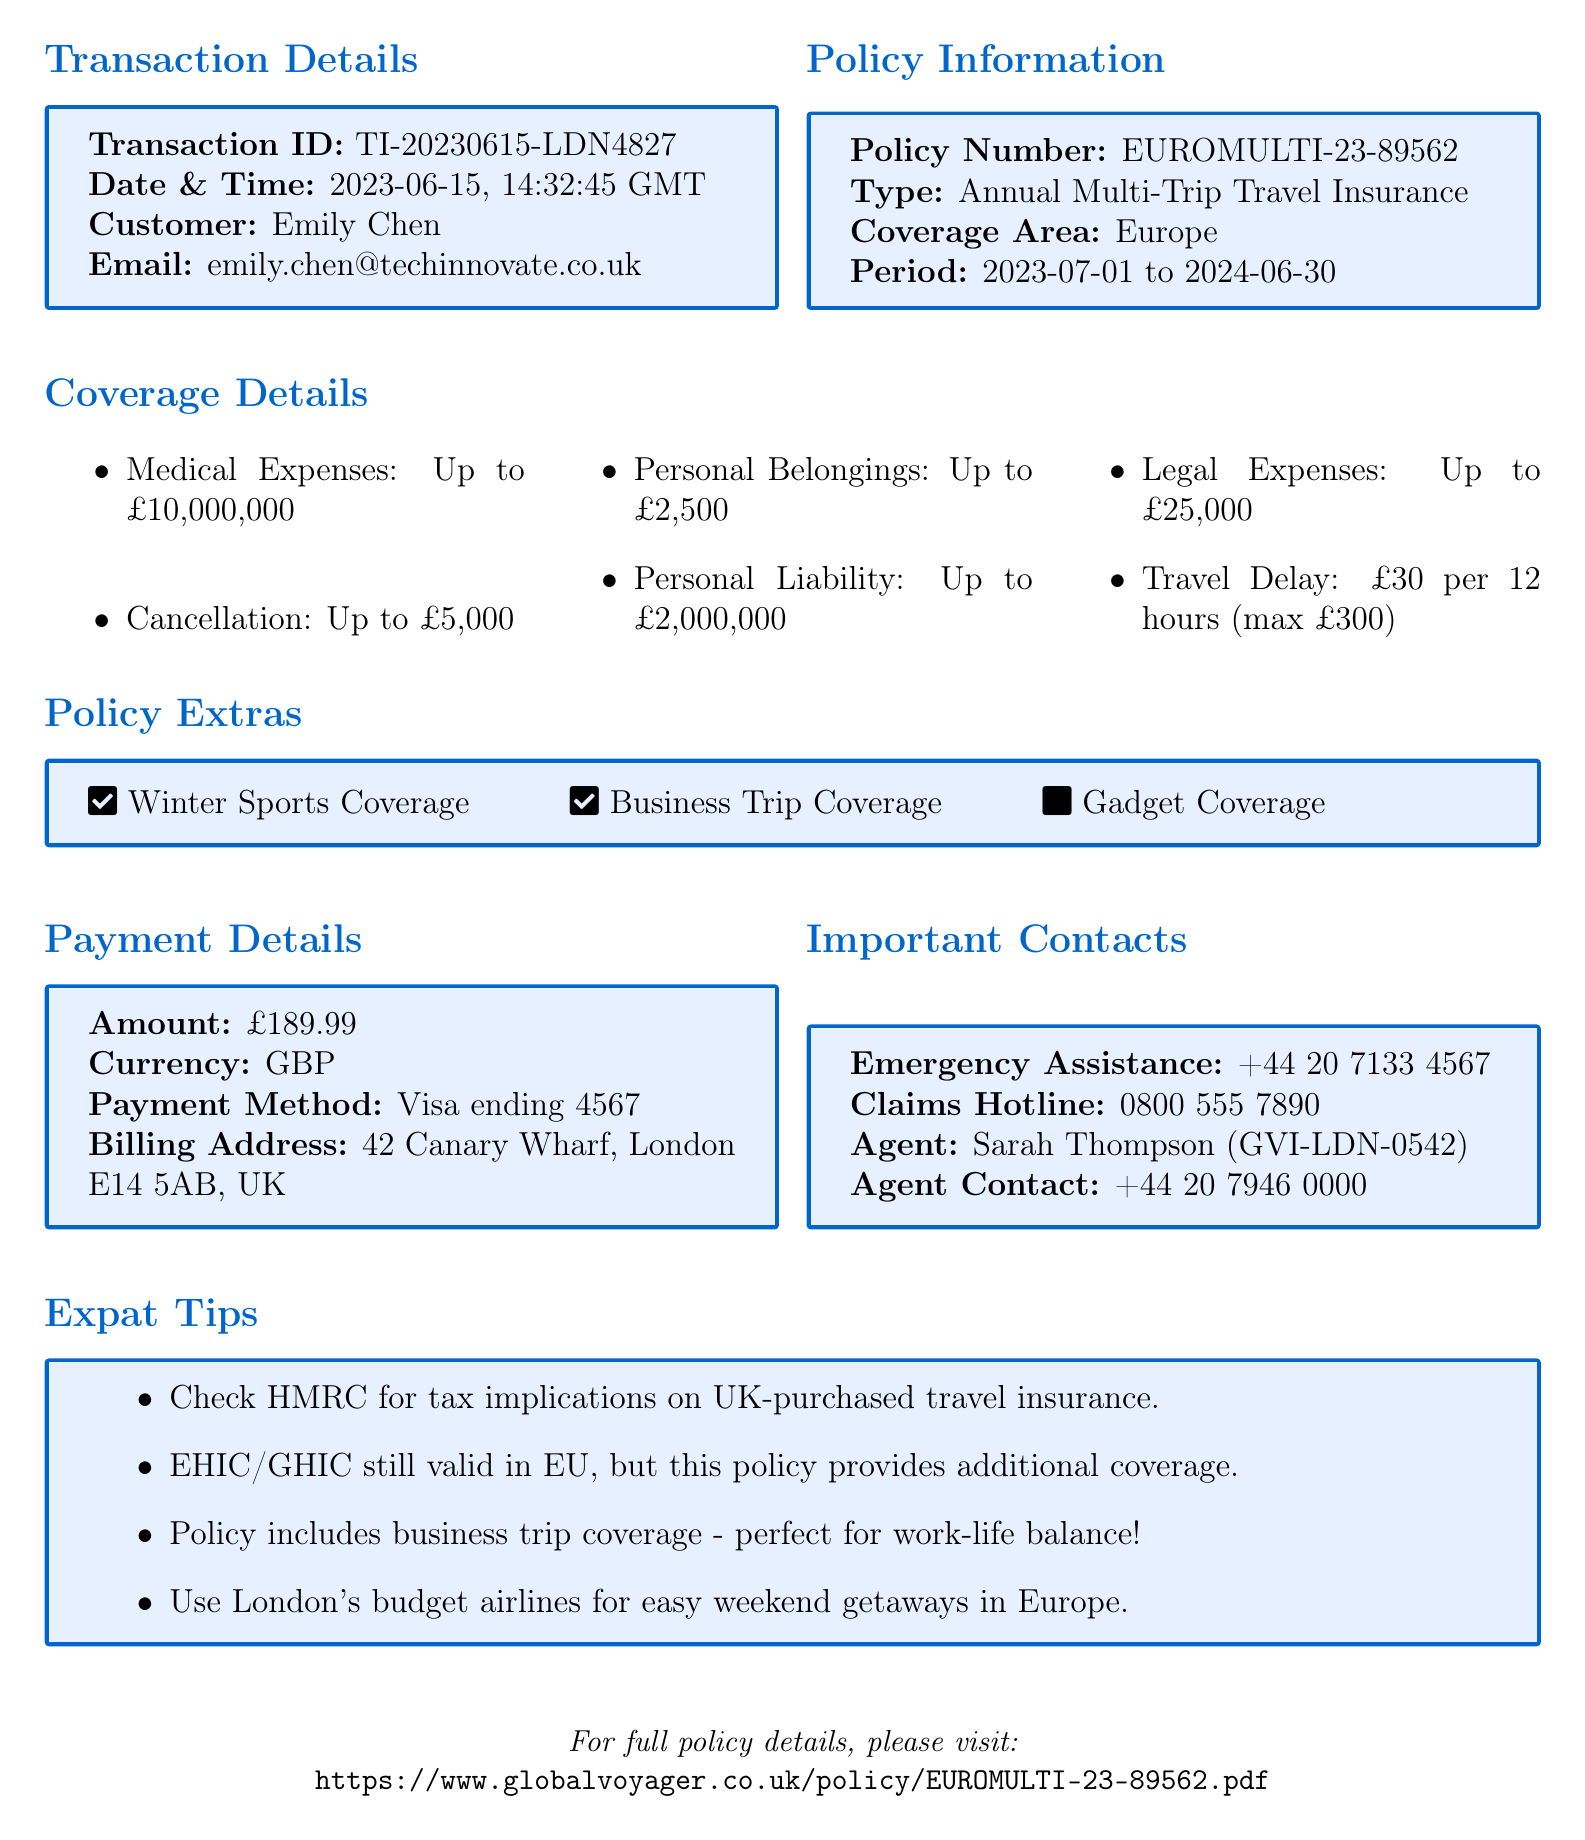What is the transaction ID? The transaction ID is a unique identifier in the document used to reference the specific transaction.
Answer: TI-20230615-LDN4827 Who is the insurance provider? The insurance provider is mentioned in the policy information section of the document.
Answer: Global Voyager Insurance What is the amount paid for the insurance? The amount paid appears in the payment details section of the document.
Answer: £189.99 What coverage area does the insurance policy cover? The coverage area indicates the geographic regions included in the insurance policy.
Answer: Europe What is the maximum coverage for medical expenses? This reflects the total amount that the policy will cover for medical expenses as noted in the coverage details section.
Answer: Up to £10,000,000 Which extra coverage is not included in the policy? This question addresses the policy extras to identify which benefits are not covered.
Answer: Gadget Coverage What is the claims hotline number? This number is provided for policyholders to contact in case of claims, specified in the important contacts section.
Answer: 0800 555 7890 How long does the insurance policy last? This refers to the duration of the insurance coverage as specified in the policy information section.
Answer: 2023-07-01 to 2024-06-30 